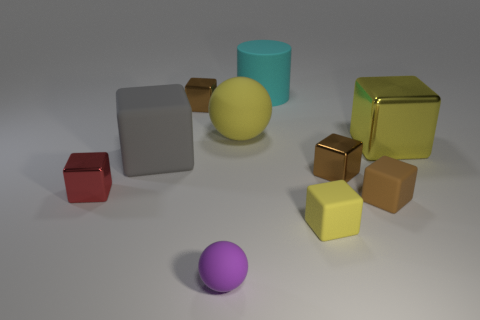Subtract all brown cylinders. How many brown cubes are left? 3 Subtract 4 cubes. How many cubes are left? 3 Subtract all gray cubes. How many cubes are left? 6 Subtract all gray cubes. How many cubes are left? 6 Subtract all green cubes. Subtract all blue cylinders. How many cubes are left? 7 Subtract all cylinders. How many objects are left? 9 Subtract 0 green cubes. How many objects are left? 10 Subtract all small purple balls. Subtract all purple things. How many objects are left? 8 Add 4 tiny purple objects. How many tiny purple objects are left? 5 Add 7 brown things. How many brown things exist? 10 